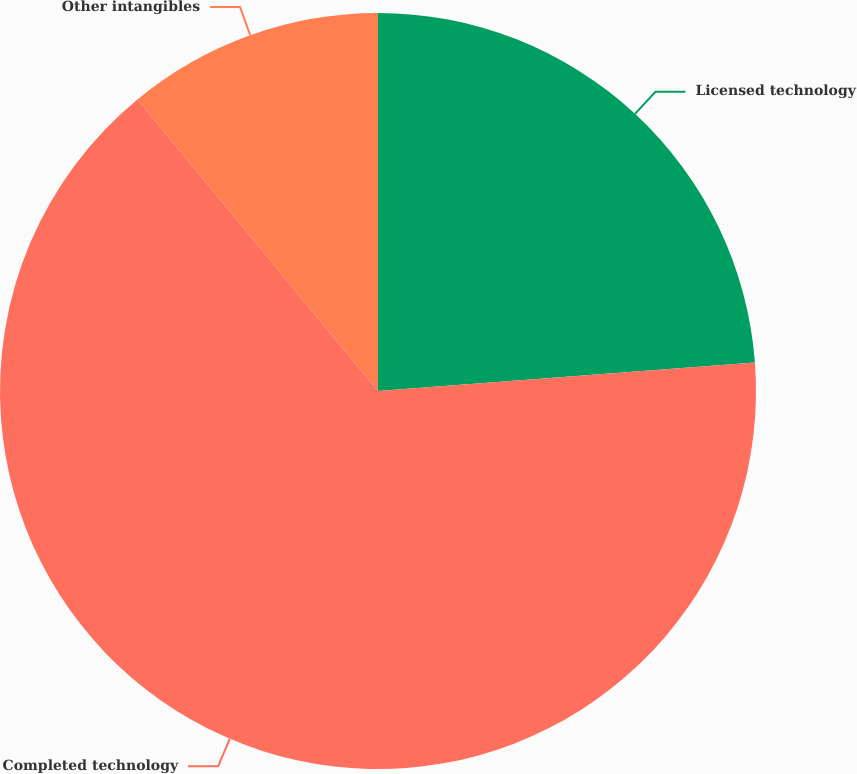Convert chart. <chart><loc_0><loc_0><loc_500><loc_500><pie_chart><fcel>Licensed technology<fcel>Completed technology<fcel>Other intangibles<nl><fcel>23.8%<fcel>65.22%<fcel>10.98%<nl></chart> 